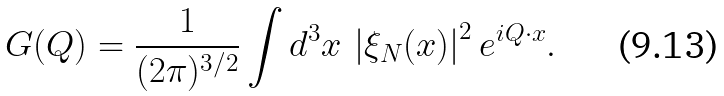Convert formula to latex. <formula><loc_0><loc_0><loc_500><loc_500>G ( { Q } ) = \frac { 1 } { ( 2 \pi ) ^ { 3 / 2 } } \int d ^ { 3 } { x } \, \left | \xi _ { N } ( { x } ) \right | ^ { 2 } e ^ { i { Q } \cdot { x } } .</formula> 